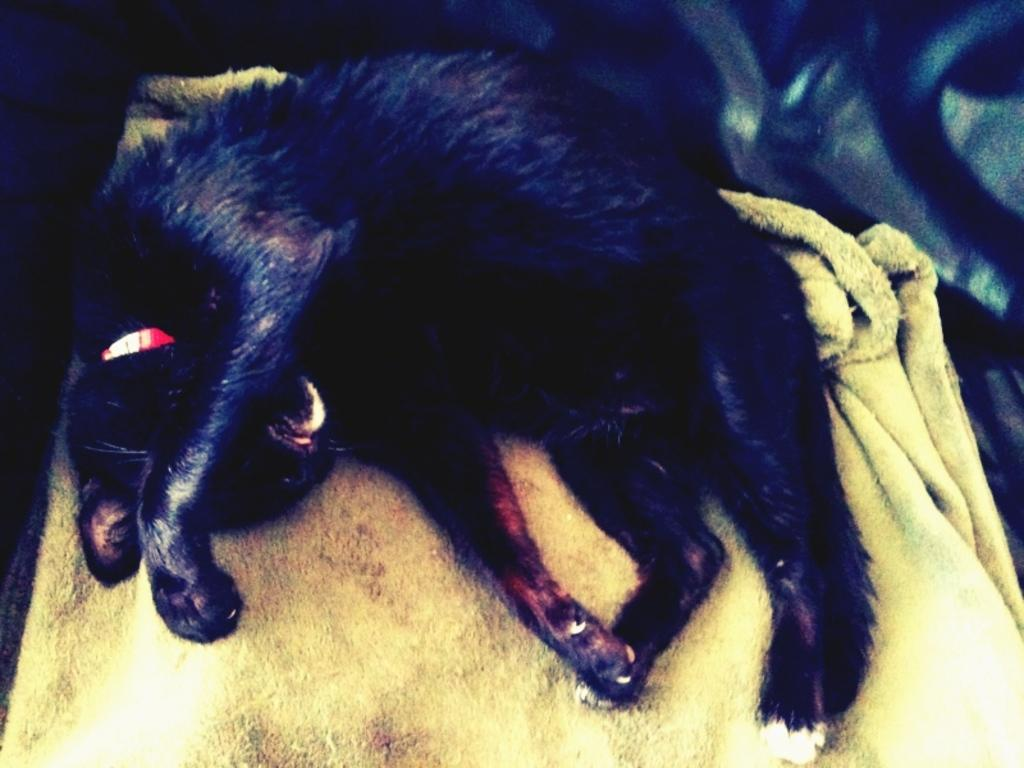What type of animal is in the picture? There is a black color cat in the picture. What is the cat sitting or lying on? The cat is on a cloth. Is there any accessory or item around the cat's neck? Yes, the cat has a red color belt around its neck. What type of oil is being used to cook the spoon in the image? There is no oil or spoon present in the image; it features a black color cat with a red color belt around its neck. 